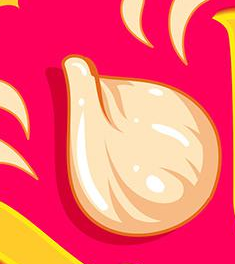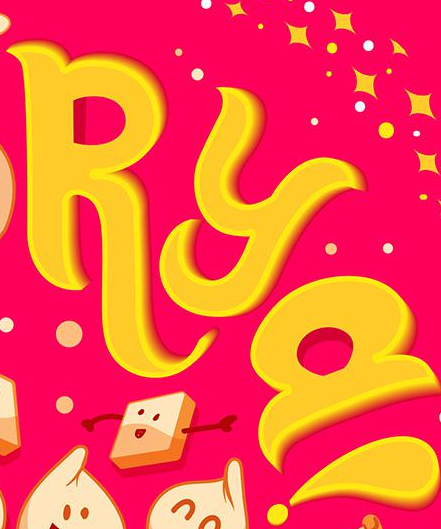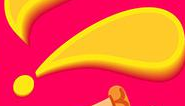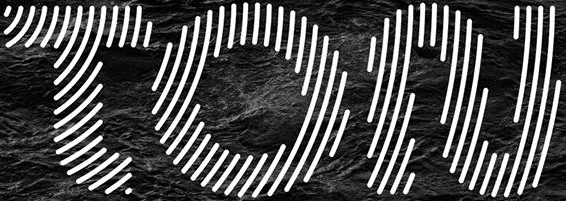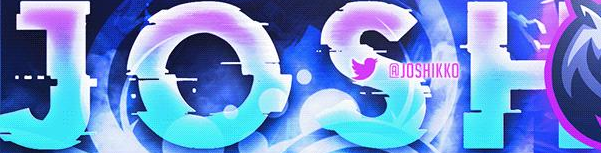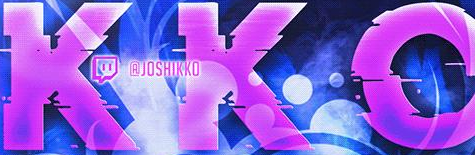Transcribe the words shown in these images in order, separated by a semicolon. #; RYa; !; TON; JOSH; KKO 